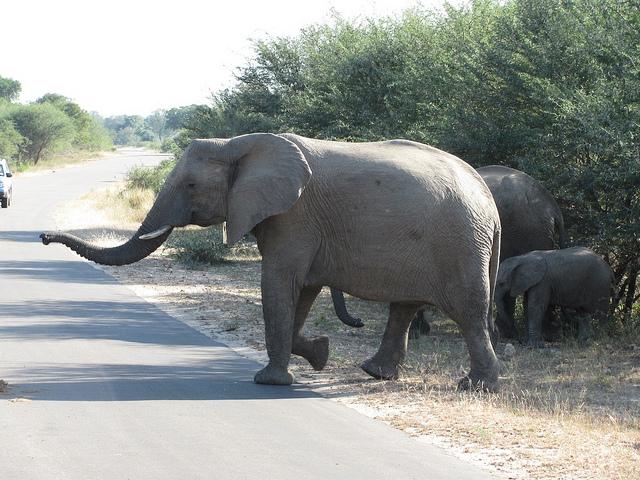Are these elephants at a zoo?
Concise answer only. No. Is the elephant crossing a road?
Give a very brief answer. Yes. Does the biggest elephant have tusks?
Give a very brief answer. Yes. Where is the baby elephant?
Short answer required. On right. Are the elephant's trunks facing upwards?
Answer briefly. Yes. Is the animal in the wild?
Concise answer only. Yes. 